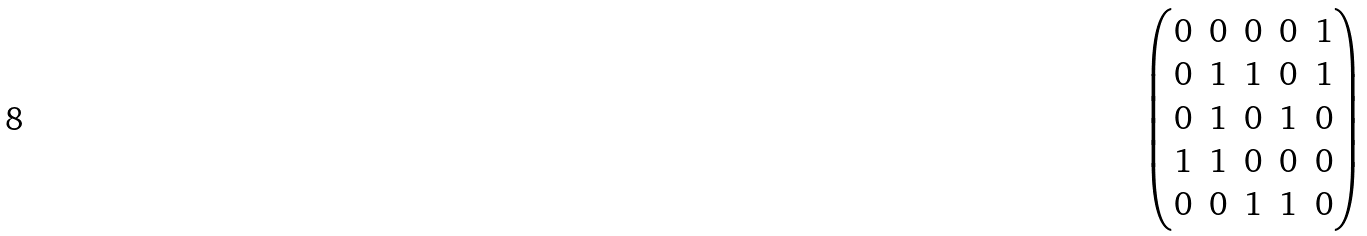<formula> <loc_0><loc_0><loc_500><loc_500>\begin{pmatrix} 0 & 0 & 0 & 0 & 1 \\ 0 & 1 & 1 & 0 & 1 \\ 0 & 1 & 0 & 1 & 0 \\ 1 & 1 & 0 & 0 & 0 \\ 0 & 0 & 1 & 1 & 0 \\ \end{pmatrix}</formula> 